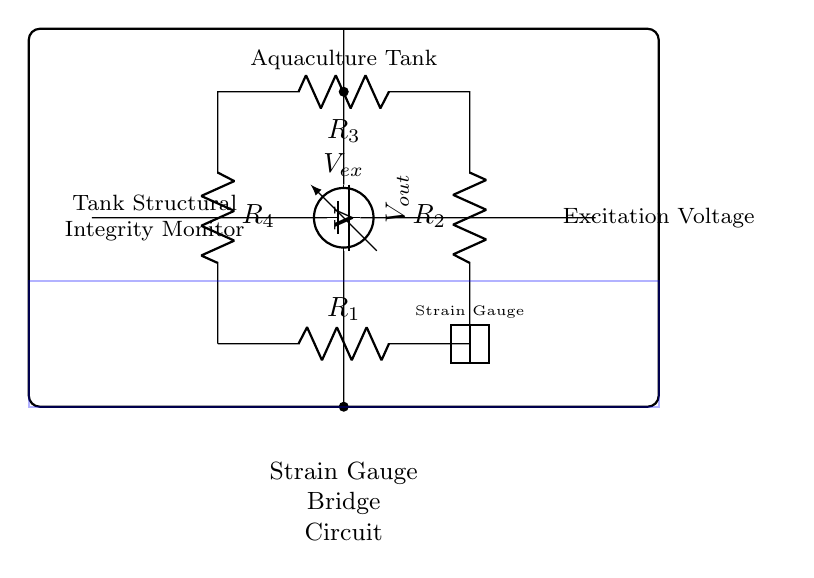What components are present in the bridge circuit? The circuit includes four resistors (R1, R2, R3, R4) and a voltmeter, as indicated in the diagram. These components are essential for forming the strain gauge bridge.
Answer: Four resistors and a voltmeter What is the purpose of the voltage source in the circuit? The voltage source, labeled as Vex, provides the necessary excitation voltage to the circuit, allowing for the measurement of structural integrity via the strain gauge.
Answer: Excitation voltage How many resistors are in the bridge configuration? There are four resistors (R1, R2, R3, R4) arranged in a bridge configuration in the circuit, which is characteristic of strain gauge bridges.
Answer: Four What does the voltmeter measure in this circuit? The voltmeter measures the potential difference (output voltage) across the bridge circuit, specifically the difference caused by the strain in the gauges, indicating structural changes.
Answer: Voltage difference How does the strain gauge relate to the aquaculture tank? The strain gauge is used to monitor changes in the structural integrity of the aquaculture tank, as deformations due to stress will affect the resistance measured by the gauges.
Answer: Structural integrity monitor What happens to the output voltage if the tank structure is compromised? If the tank structure is compromised, the output voltage will change due to the resistance variation in the strain gauge, signaling potential failure or stress.
Answer: Output voltage changes What is the significance of the rectangle drawn around the circuit? The rectangle indicates the physical boundaries of the aquaculture tank, showing that the circuit's purpose is to monitor the integrity of that specific structure.
Answer: Aquaculture tank boundary 